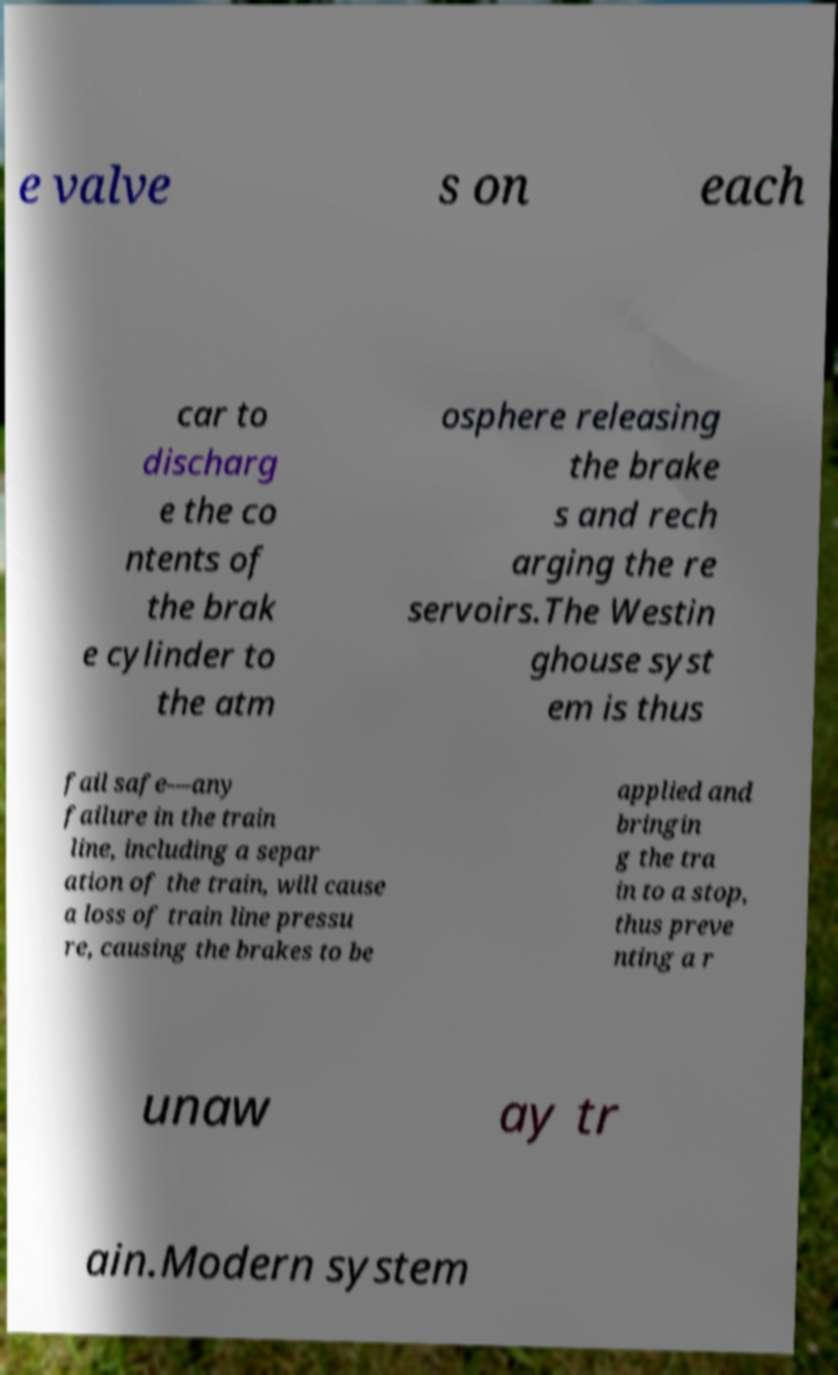Could you assist in decoding the text presented in this image and type it out clearly? e valve s on each car to discharg e the co ntents of the brak e cylinder to the atm osphere releasing the brake s and rech arging the re servoirs.The Westin ghouse syst em is thus fail safe—any failure in the train line, including a separ ation of the train, will cause a loss of train line pressu re, causing the brakes to be applied and bringin g the tra in to a stop, thus preve nting a r unaw ay tr ain.Modern system 